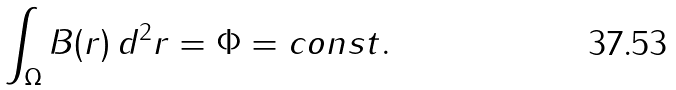<formula> <loc_0><loc_0><loc_500><loc_500>\int _ { \Omega } B ( { r } ) \, d ^ { 2 } { r } = \Phi = c o n s t .</formula> 